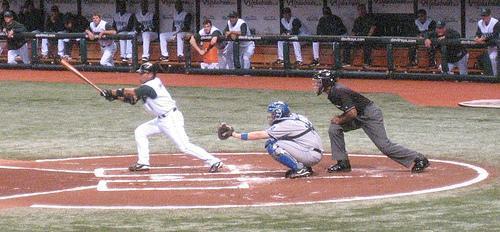How many people are playing baseball in the photo?
Give a very brief answer. 3. How many people are there?
Give a very brief answer. 4. 